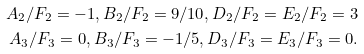<formula> <loc_0><loc_0><loc_500><loc_500>A _ { 2 } / F _ { 2 } = - 1 , B _ { 2 } / F _ { 2 } = 9 / 1 0 , D _ { 2 } / F _ { 2 } = E _ { 2 } / F _ { 2 } = 3 \\ A _ { 3 } / F _ { 3 } = 0 , B _ { 3 } / F _ { 3 } = - 1 / 5 , D _ { 3 } / F _ { 3 } = E _ { 3 } / F _ { 3 } = 0 .</formula> 